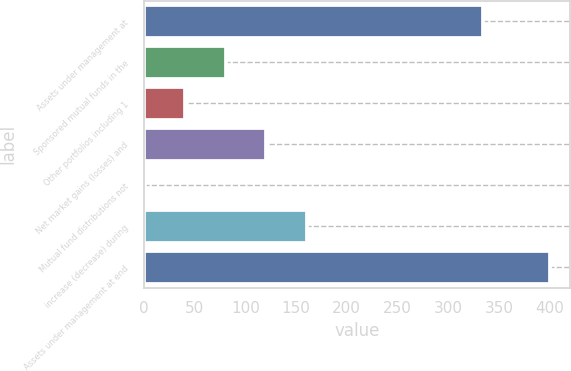<chart> <loc_0><loc_0><loc_500><loc_500><bar_chart><fcel>Assets under management at<fcel>Sponsored mutual funds in the<fcel>Other portfolios including 1<fcel>Net market gains (losses) and<fcel>Mutual fund distributions not<fcel>increase (decrease) during<fcel>Assets under management at end<nl><fcel>334.7<fcel>80.72<fcel>40.81<fcel>120.63<fcel>0.9<fcel>160.54<fcel>400<nl></chart> 